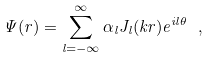Convert formula to latex. <formula><loc_0><loc_0><loc_500><loc_500>\Psi ( { r } ) = \sum _ { l = - \infty } ^ { \infty } \alpha _ { l } J _ { l } ( k r ) e ^ { i l \theta } \ ,</formula> 